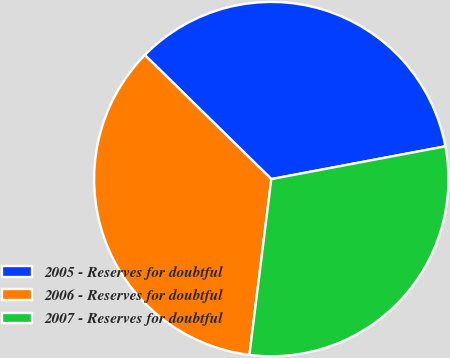Convert chart to OTSL. <chart><loc_0><loc_0><loc_500><loc_500><pie_chart><fcel>2005 - Reserves for doubtful<fcel>2006 - Reserves for doubtful<fcel>2007 - Reserves for doubtful<nl><fcel>34.69%<fcel>35.37%<fcel>29.93%<nl></chart> 